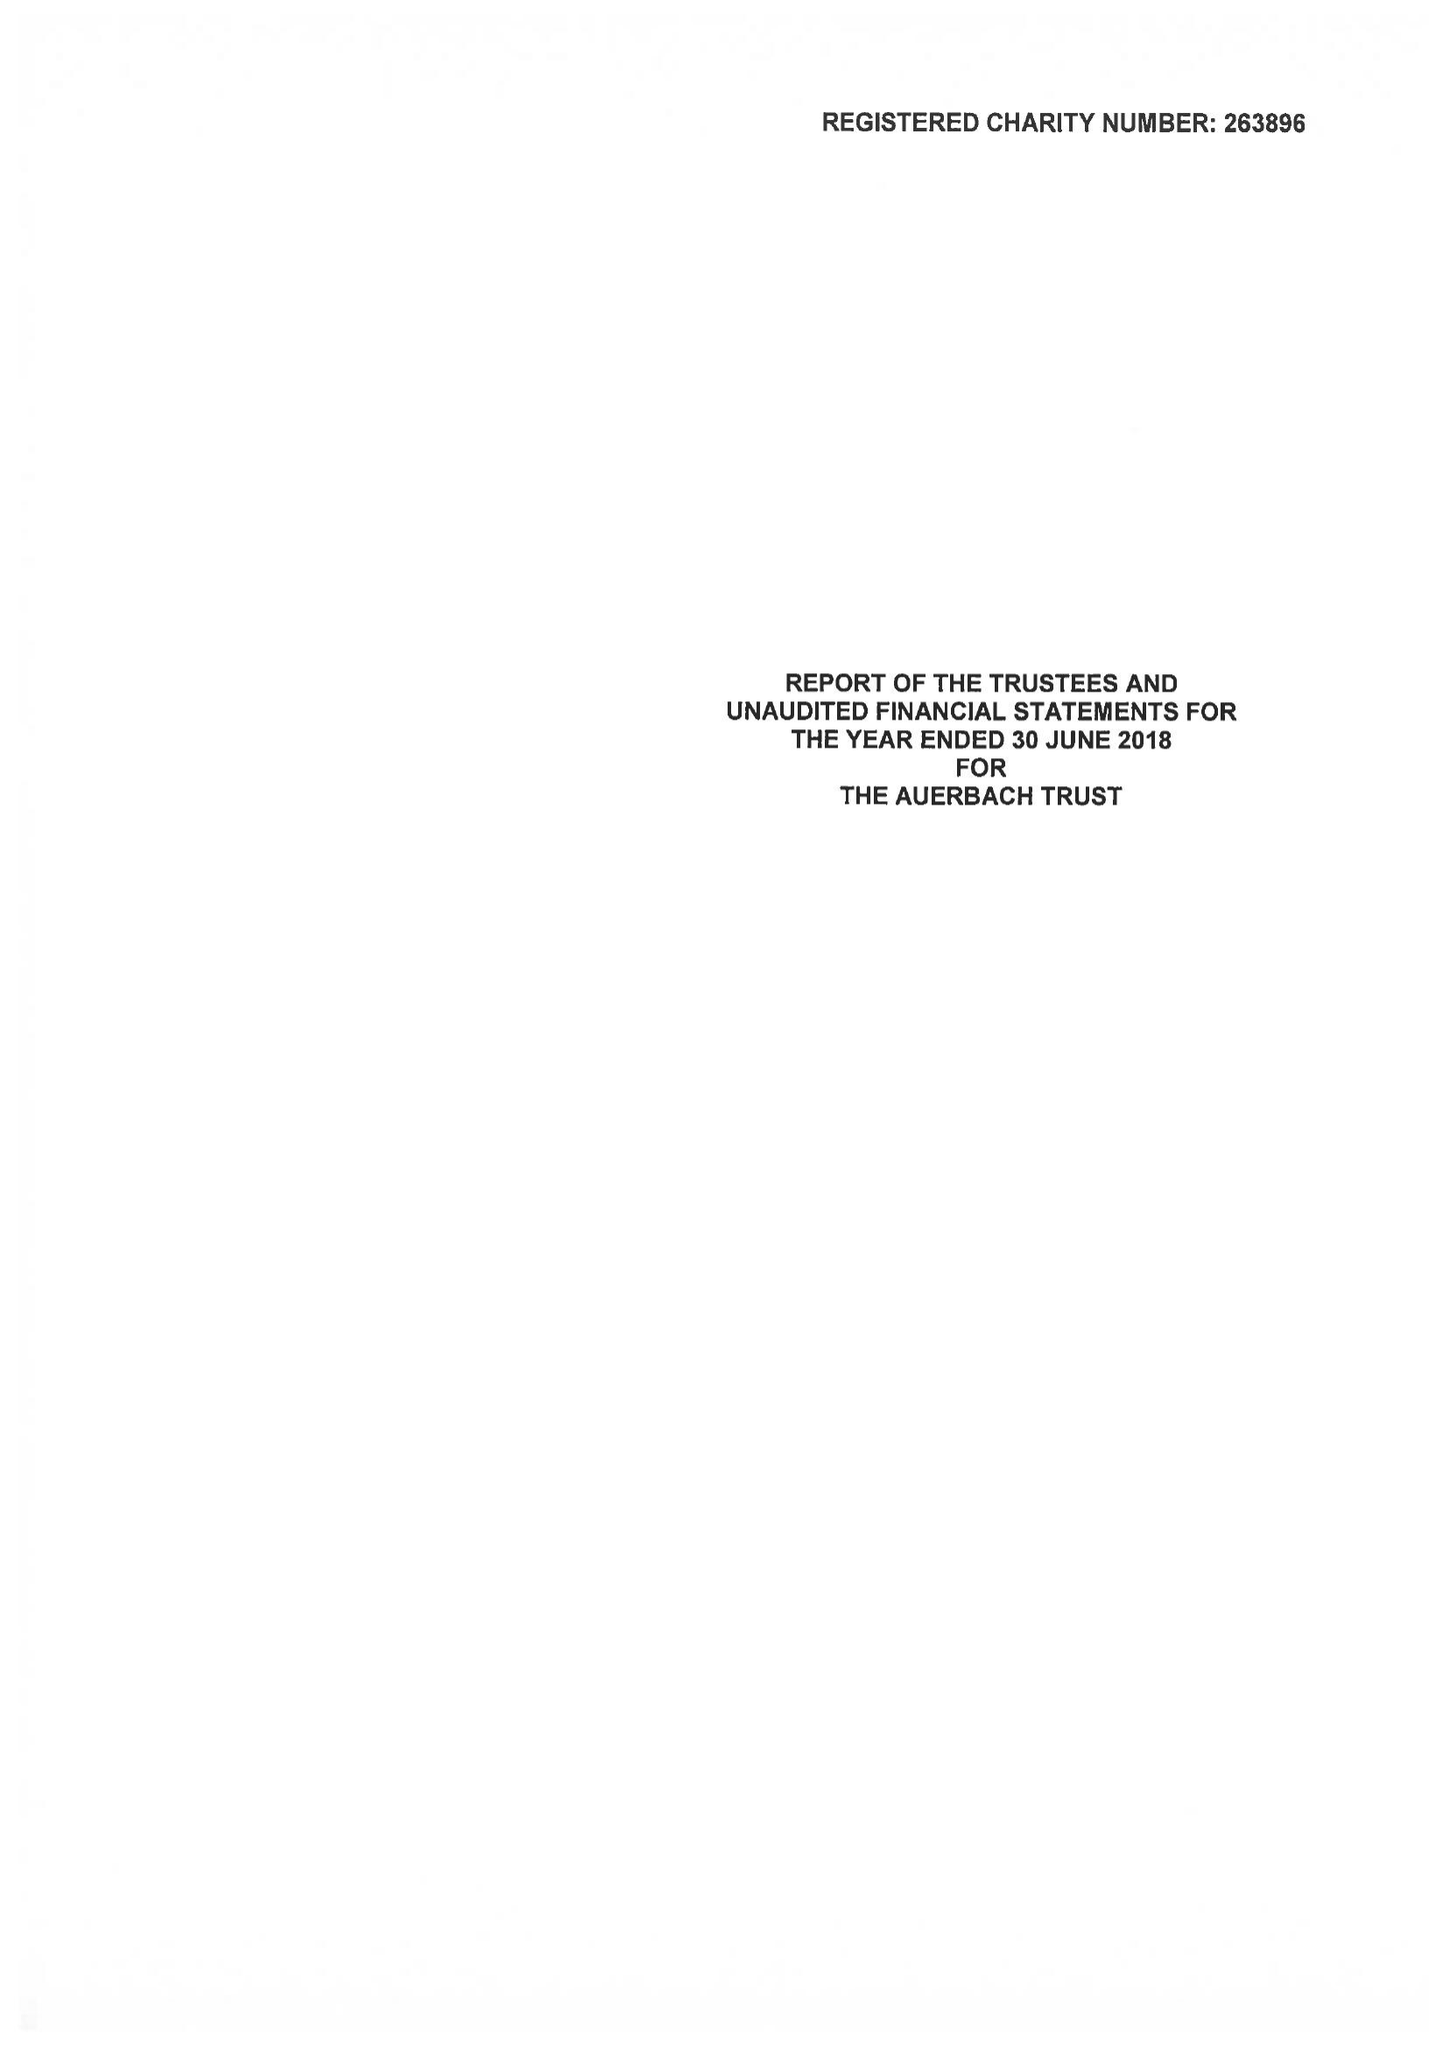What is the value for the report_date?
Answer the question using a single word or phrase. 2018-06-30 